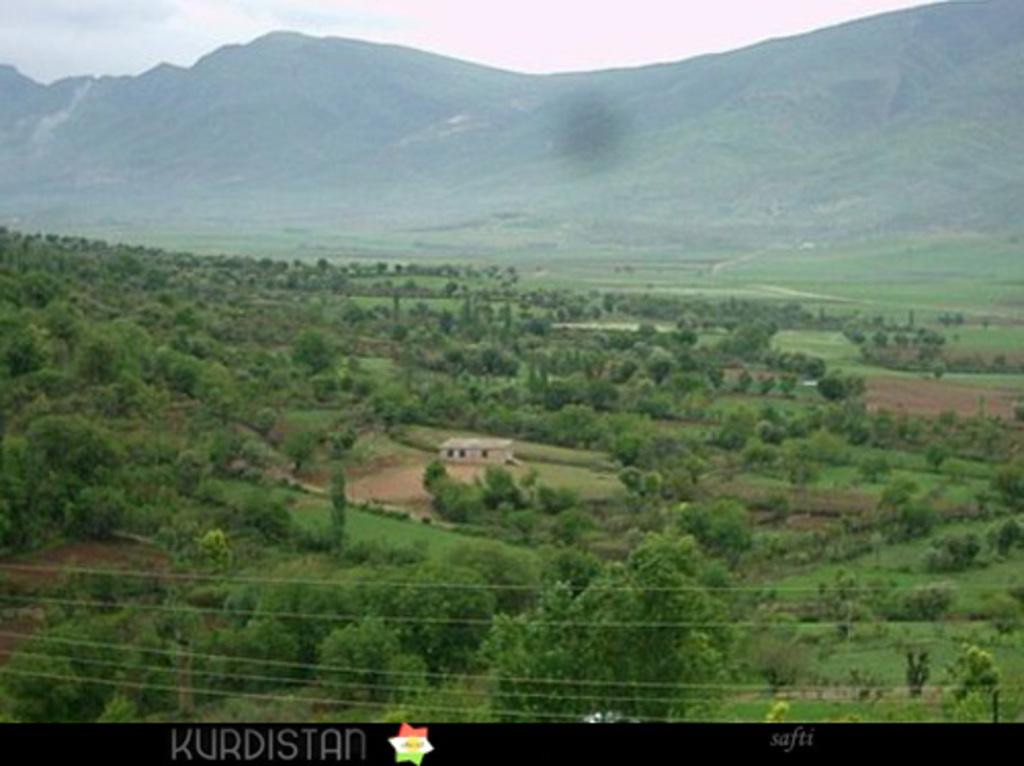What is featured in the image that represents a symbol or brand? There is a logo in the image. What type of written information is present in the image? There is text in the image. What type of man-made structures can be seen in the image? There are wires, a house, and farms in the image. What type of natural elements can be seen in the image? There are trees, grass, plants, mountains, and the sky in the image. What might suggest the location or setting of the image? The presence of mountains and the possible location near the mountains may suggest a rural or mountainous setting. How does the rod affect the movement of the trees in the image? There is no rod present in the image, so it cannot affect the movement of the trees. 